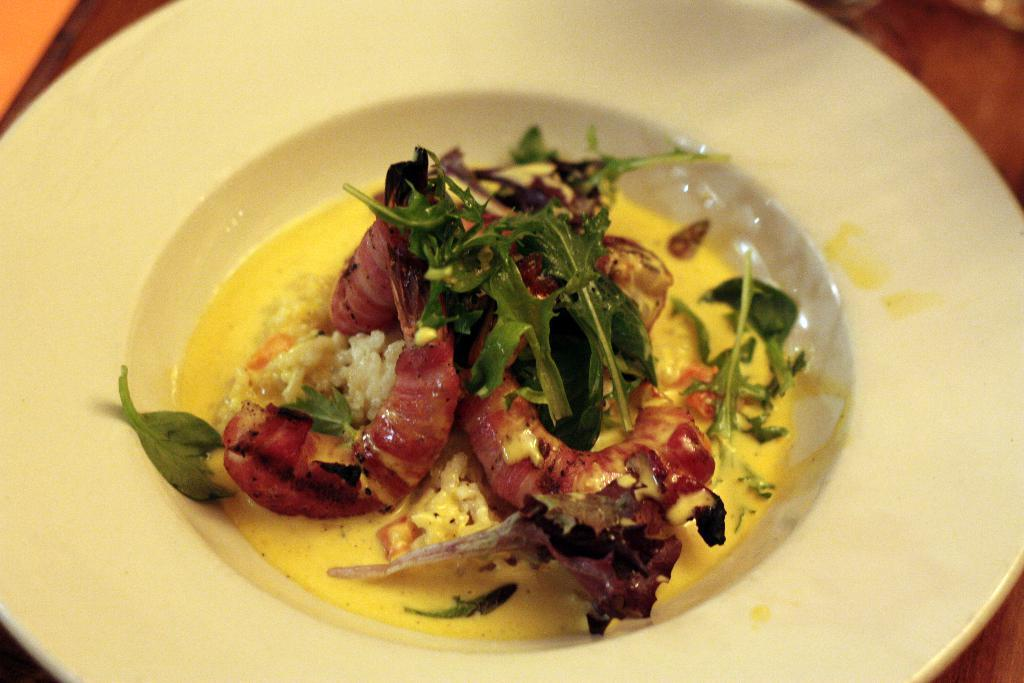What types of food items can be seen in the image? There are leaves and other food items in the image. How are the food items arranged in the image? The food items are arranged on a white color plate. Can you describe the background of the image? The background of the image is blurred. What type of behavior can be observed in the jellyfish in the image? There are no jellyfish present in the image; it features leaves and other food items arranged on a white color plate with a blurred background. 